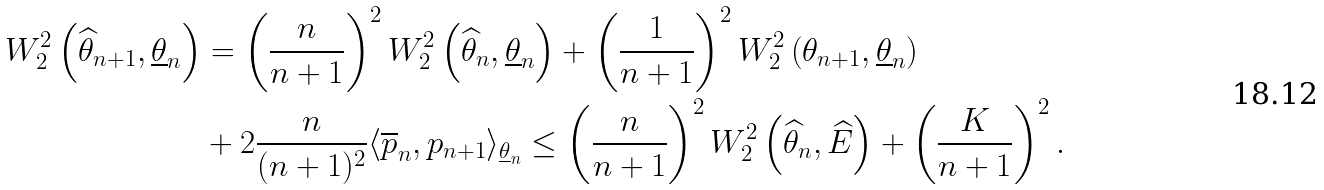<formula> <loc_0><loc_0><loc_500><loc_500>W _ { 2 } ^ { 2 } \left ( \widehat { \theta } _ { n + 1 } , \underline { \theta } _ { n } \right ) & = \left ( \frac { n } { n + 1 } \right ) ^ { 2 } W _ { 2 } ^ { 2 } \left ( \widehat { \theta } _ { n } , \underline { \theta } _ { n } \right ) + \left ( \frac { 1 } { n + 1 } \right ) ^ { 2 } W _ { 2 } ^ { 2 } \left ( \theta _ { n + 1 } , \underline { \theta } _ { n } \right ) \\ & + 2 \frac { n } { ( n + 1 ) ^ { 2 } } \langle \overline { p } _ { n } , p _ { n + 1 } \rangle _ { \underline { \theta } _ { n } } \leq \left ( \frac { n } { n + 1 } \right ) ^ { 2 } W _ { 2 } ^ { 2 } \left ( \widehat { \theta } _ { n } , \widehat { E } \right ) + \left ( \frac { K } { n + 1 } \right ) ^ { 2 } .</formula> 